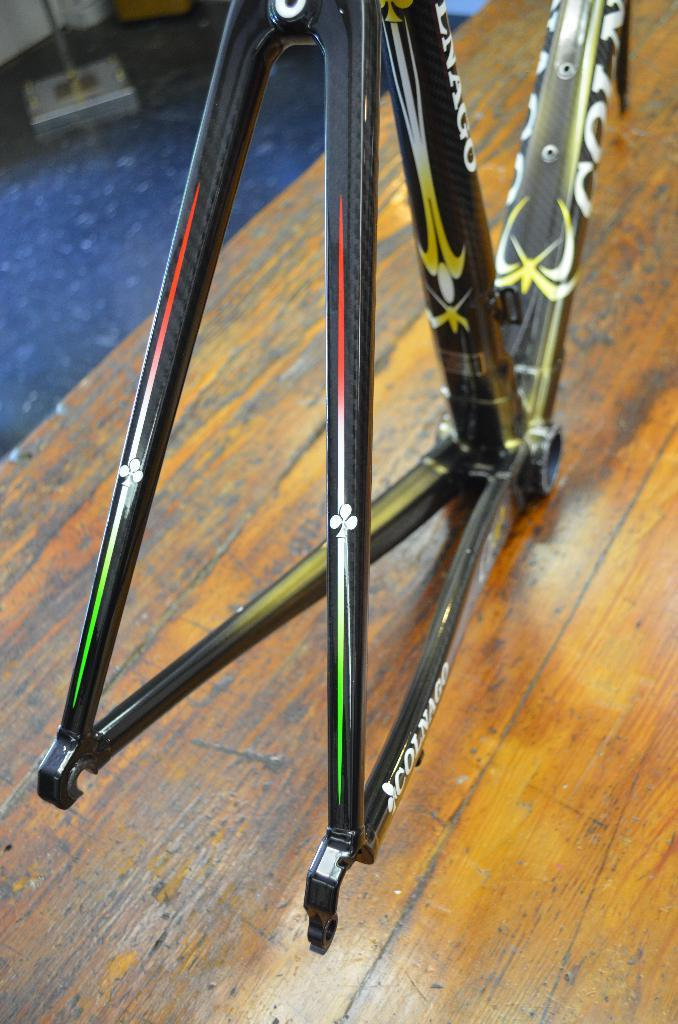What is the main object on the wooden surface in the image? There is a metal object on a wooden surface in the image. Can you describe the objects on the floor in the background of the image? Unfortunately, the provided facts do not give any information about the objects on the floor in the background of the image. What type of surprise can be seen inside the tent in the image? There is no tent present in the image, so it is not possible to answer that question. 